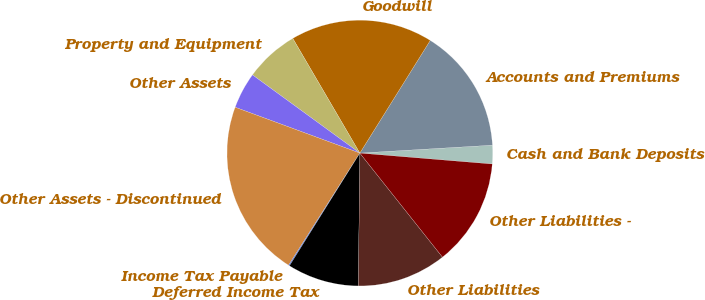Convert chart. <chart><loc_0><loc_0><loc_500><loc_500><pie_chart><fcel>Cash and Bank Deposits<fcel>Accounts and Premiums<fcel>Goodwill<fcel>Property and Equipment<fcel>Other Assets<fcel>Other Assets - Discontinued<fcel>Income Tax Payable<fcel>Deferred Income Tax<fcel>Other Liabilities<fcel>Other Liabilities -<nl><fcel>2.26%<fcel>15.16%<fcel>17.31%<fcel>6.56%<fcel>4.41%<fcel>21.6%<fcel>0.12%<fcel>8.71%<fcel>10.86%<fcel>13.01%<nl></chart> 